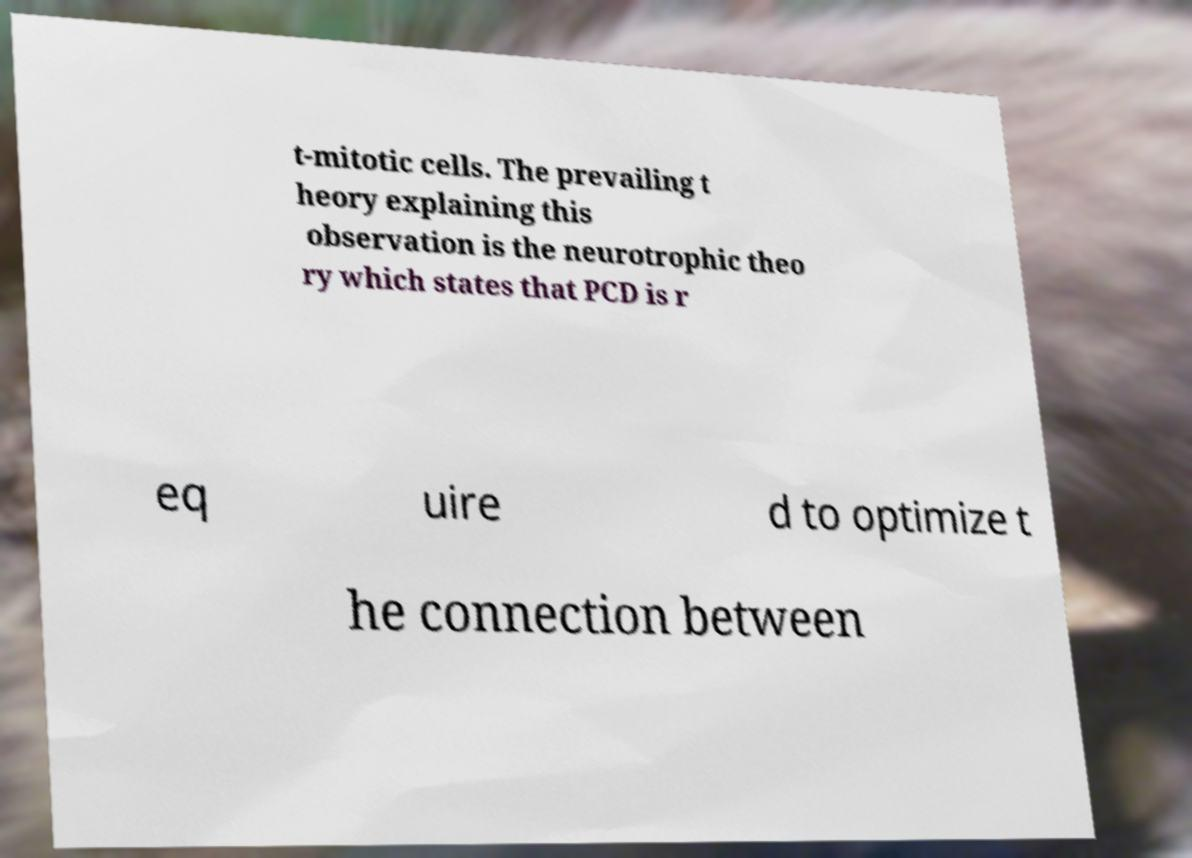Could you extract and type out the text from this image? t-mitotic cells. The prevailing t heory explaining this observation is the neurotrophic theo ry which states that PCD is r eq uire d to optimize t he connection between 